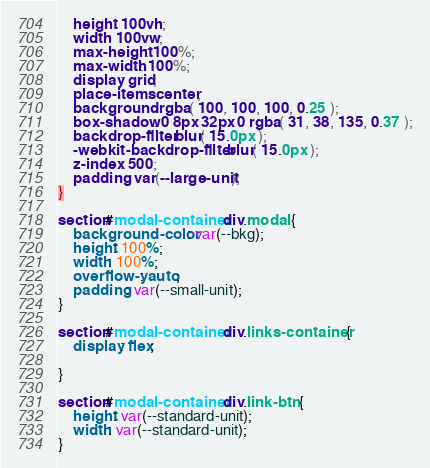<code> <loc_0><loc_0><loc_500><loc_500><_CSS_>	height: 100vh;
	width: 100vw;
	max-height: 100%;
	max-width: 100%;
	display: grid;
	place-items: center;
	background: rgba( 100, 100, 100, 0.25 );
	box-shadow: 0 8px 32px 0 rgba( 31, 38, 135, 0.37 );
	backdrop-filter: blur( 15.0px );
	-webkit-backdrop-filter: blur( 15.0px );
	z-index: 500;
	padding: var(--large-unit);
}

section#modal-container div.modal {
	background-color: var(--bkg);
	height: 100%;
	width: 100%;
	overflow-y: auto;
	padding: var(--small-unit);
}

section#modal-container div.links-container {
	display: flex;

}

section#modal-container div.link-btn {
	height: var(--standard-unit);
	width: var(--standard-unit);
}
</code> 